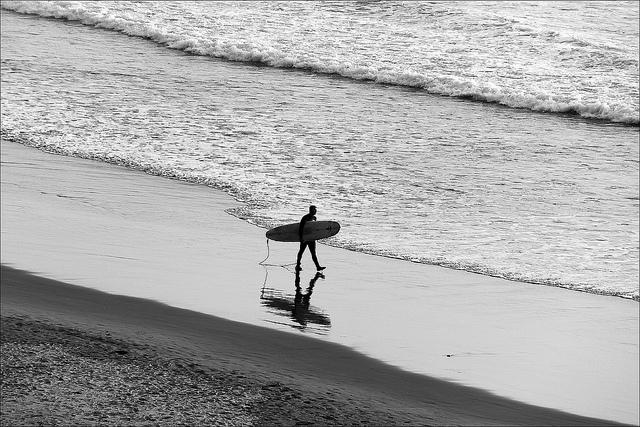Is the man going to surf in the ocean?
Short answer required. Yes. Can this man swim?
Write a very short answer. Yes. What is this man holding?
Quick response, please. Surfboard. 